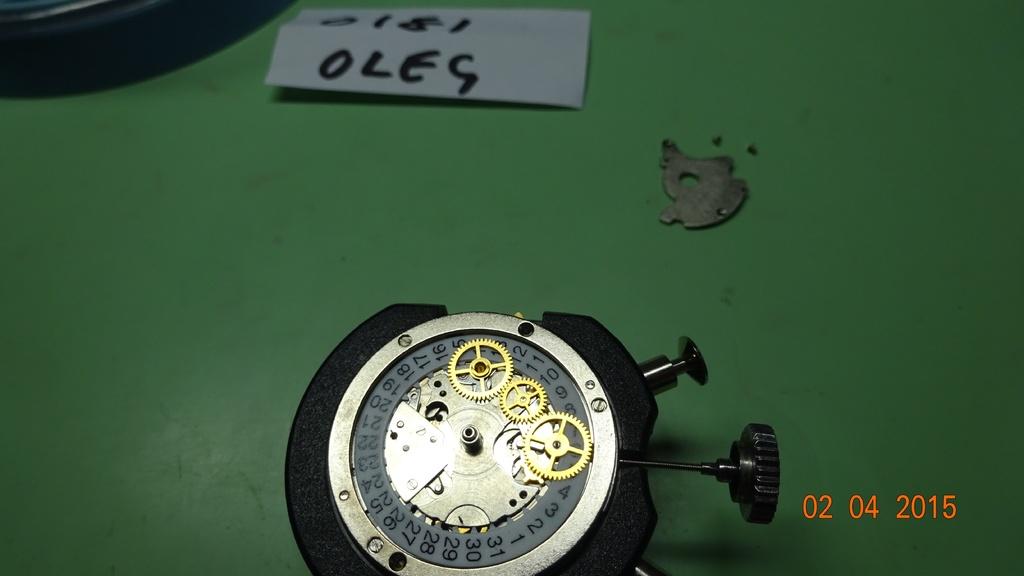What is the date on the photo?
Your answer should be compact. 02 04 2015. The blue paper at the top has a name, it is?
Give a very brief answer. Oleg. 